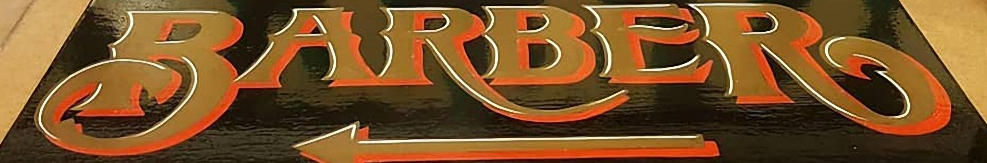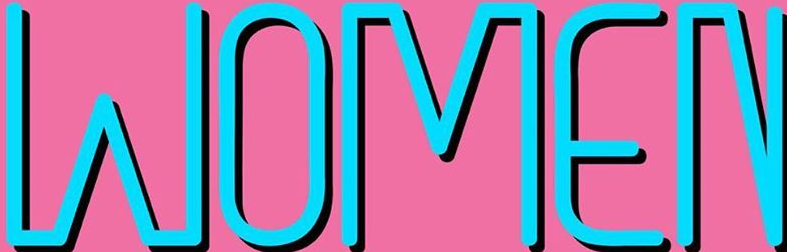What words can you see in these images in sequence, separated by a semicolon? BARBER; WOMEN 